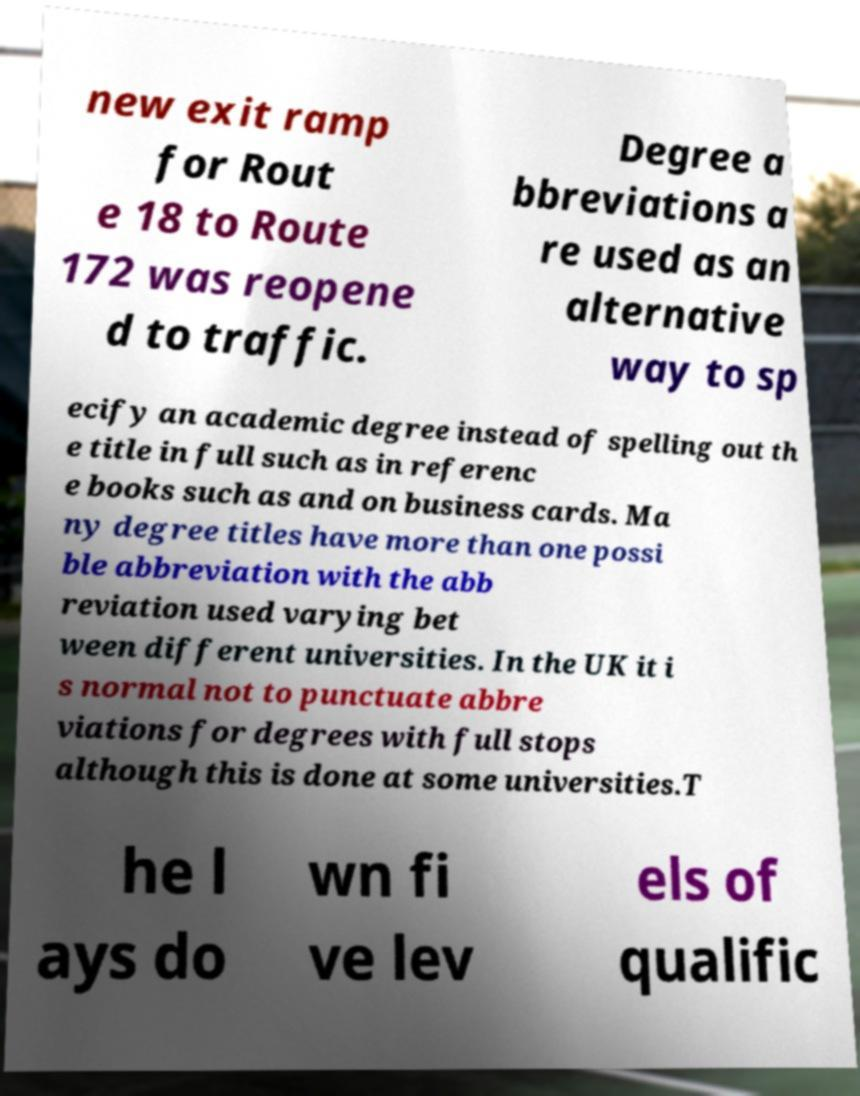Could you assist in decoding the text presented in this image and type it out clearly? new exit ramp for Rout e 18 to Route 172 was reopene d to traffic. Degree a bbreviations a re used as an alternative way to sp ecify an academic degree instead of spelling out th e title in full such as in referenc e books such as and on business cards. Ma ny degree titles have more than one possi ble abbreviation with the abb reviation used varying bet ween different universities. In the UK it i s normal not to punctuate abbre viations for degrees with full stops although this is done at some universities.T he l ays do wn fi ve lev els of qualific 